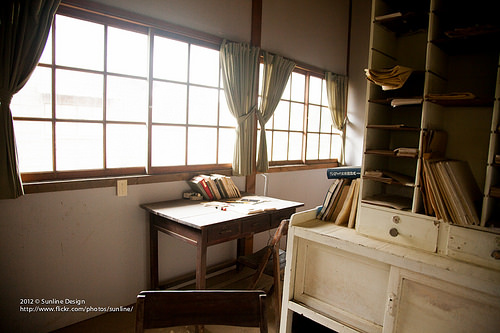<image>
Is there a books next to the curtains? Yes. The books is positioned adjacent to the curtains, located nearby in the same general area. 